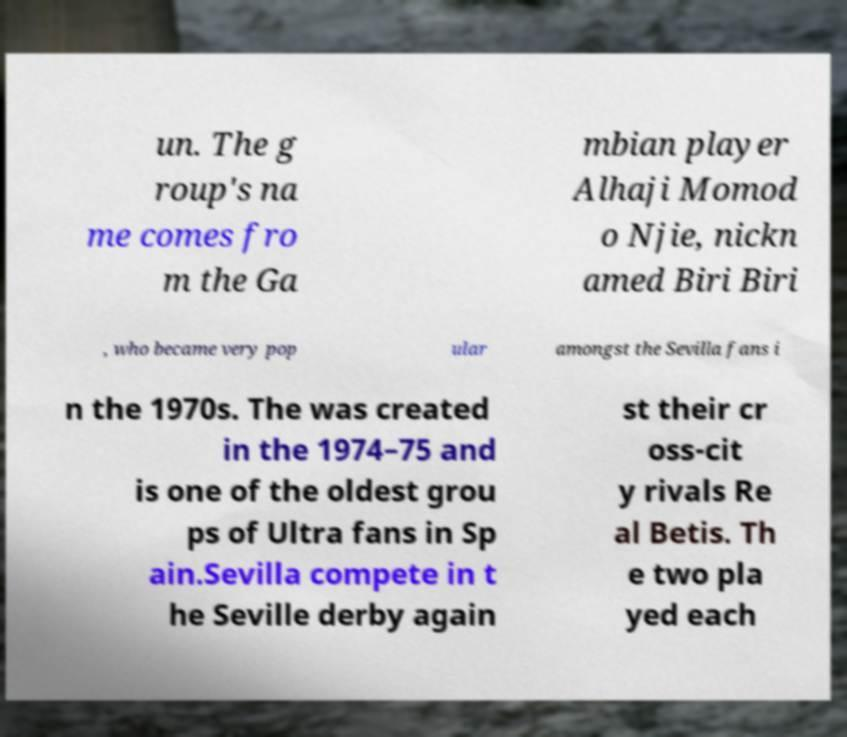Please identify and transcribe the text found in this image. un. The g roup's na me comes fro m the Ga mbian player Alhaji Momod o Njie, nickn amed Biri Biri , who became very pop ular amongst the Sevilla fans i n the 1970s. The was created in the 1974–75 and is one of the oldest grou ps of Ultra fans in Sp ain.Sevilla compete in t he Seville derby again st their cr oss-cit y rivals Re al Betis. Th e two pla yed each 